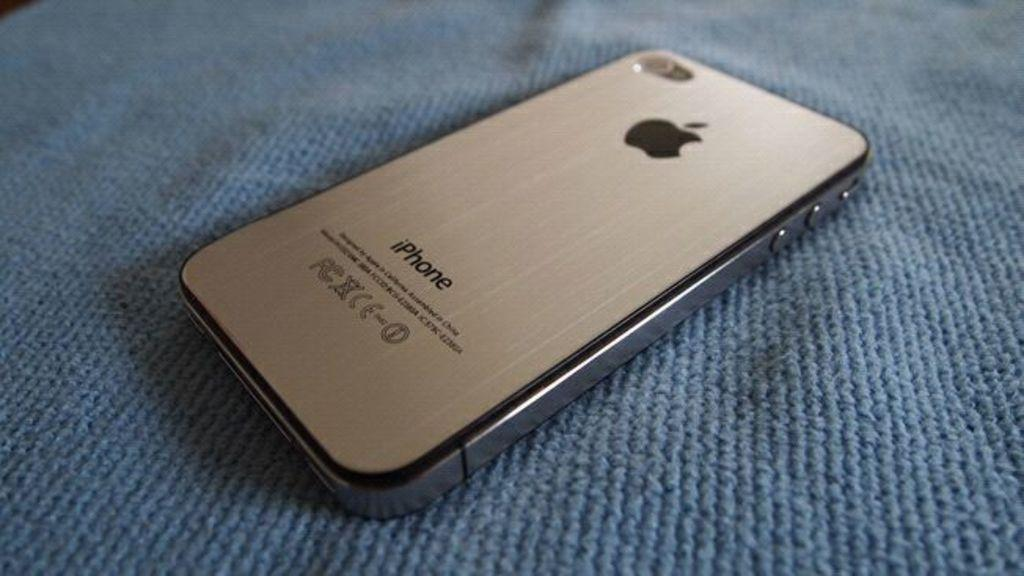<image>
Render a clear and concise summary of the photo. Silver tone Iphone laying on a piece of blue fabric. 